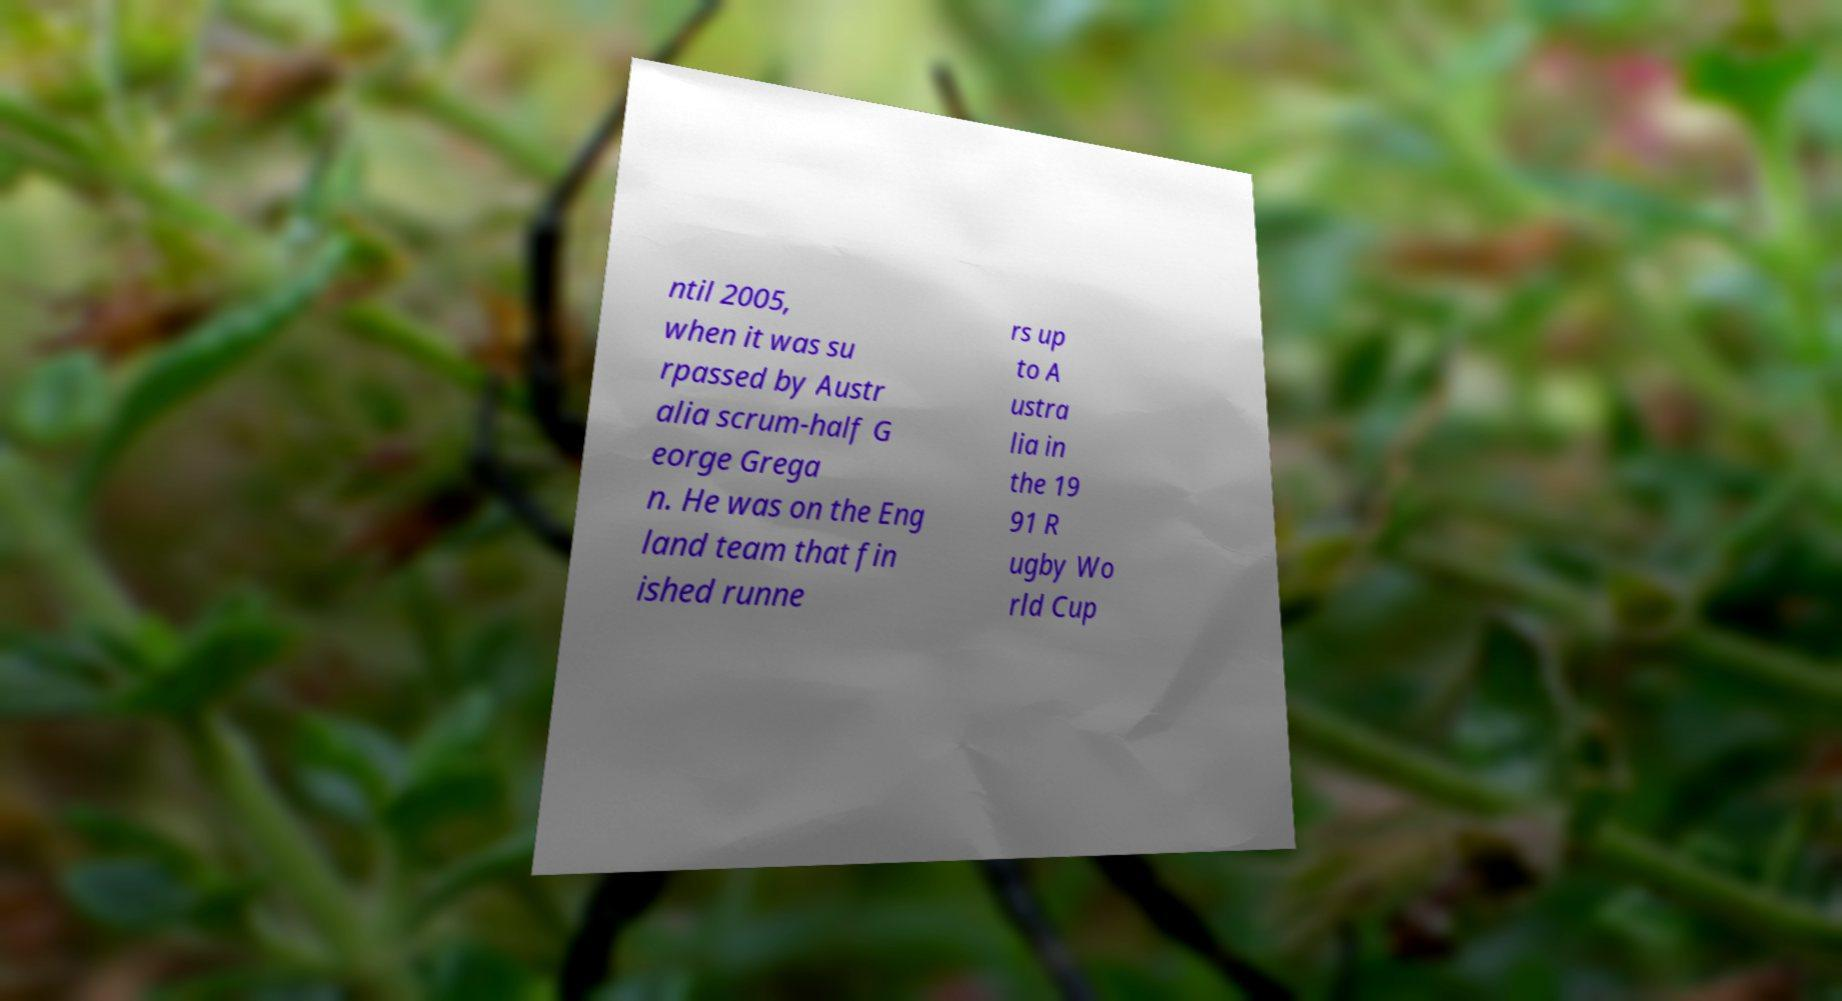What messages or text are displayed in this image? I need them in a readable, typed format. ntil 2005, when it was su rpassed by Austr alia scrum-half G eorge Grega n. He was on the Eng land team that fin ished runne rs up to A ustra lia in the 19 91 R ugby Wo rld Cup 